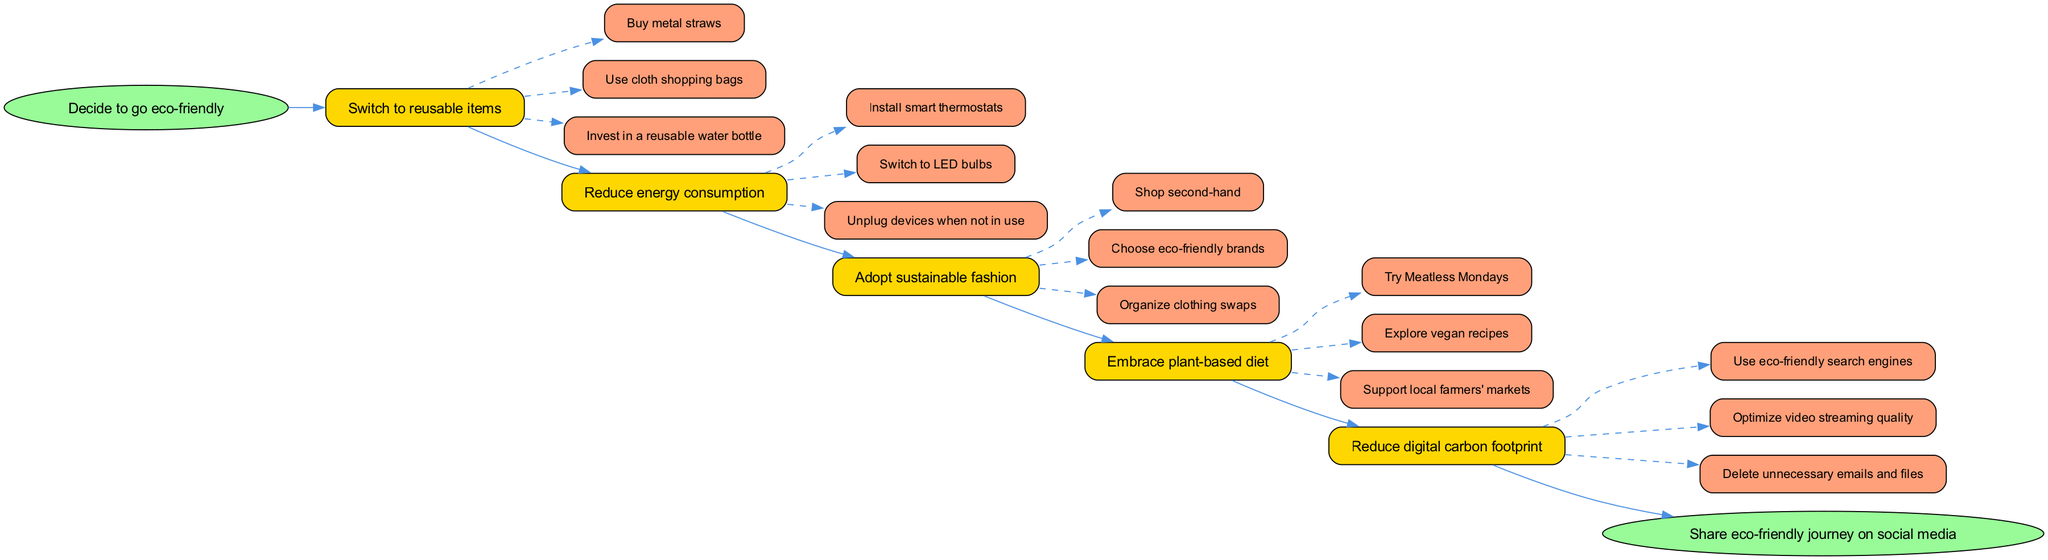What is the starting point of the clinical pathway? The starting point is clearly labeled in the diagram as "Decide to go eco-friendly." This node is shaped as an ellipse, signifying the initial action in the pathway.
Answer: Decide to go eco-friendly How many main steps are outlined in the diagram? To find the number of main steps, we count the individual steps listed under the "steps" section of the data. There are five distinct steps that guide the eco-friendly transition.
Answer: 5 What action is linked to the step "Reduce energy consumption"? By examining the "Reduce energy consumption" step, we can see the actions listed beneath it. The action "Install smart thermostats" directly follows as a key action linked to this step.
Answer: Install smart thermostats Which step involves a focus on clothing? Looking through the steps, "Adopt sustainable fashion" explicitly mentions actions related to clothing, such as shopping second-hand and organizing clothing swaps. Thus, this step is focused on clothing.
Answer: Adopt sustainable fashion What is the last action before the end node in the pathway? The last step listed before reaching the end node is "Reduce digital carbon footprint." Its final action is "Delete unnecessary emails and files," linking this action directly to the end process.
Answer: Delete unnecessary emails and files What is the final outcome of the diagram? The end node clearly states "Share eco-friendly journey on social media," which indicates the ultimate goal of the clinical pathway after transitioning to an eco-friendly lifestyle.
Answer: Share eco-friendly journey on social media What color is assigned to the actions in the diagram? Each action within the steps is colored with a shade represented in the diagram as '#FFA07A', indicating a uniform color for all the actions to create consistency.
Answer: #FFA07A Which step precedes "Embrace plant-based diet"? By tracing through the steps, we observe that "Adopt sustainable fashion" is linked directly to the step before "Embrace plant-based diet," establishing a sequential order within the pathway.
Answer: Adopt sustainable fashion 